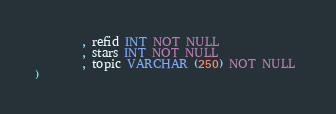Convert code to text. <code><loc_0><loc_0><loc_500><loc_500><_SQL_>		, refid INT NOT NULL 
		, stars INT NOT NULL 
		, topic VARCHAR (250) NOT NULL 
)
</code> 